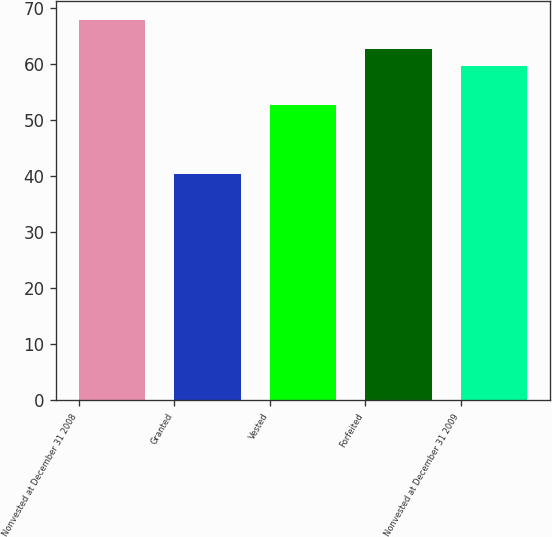Convert chart. <chart><loc_0><loc_0><loc_500><loc_500><bar_chart><fcel>Nonvested at December 31 2008<fcel>Granted<fcel>Vested<fcel>Forfeited<fcel>Nonvested at December 31 2009<nl><fcel>67.95<fcel>40.47<fcel>52.7<fcel>62.74<fcel>59.6<nl></chart> 